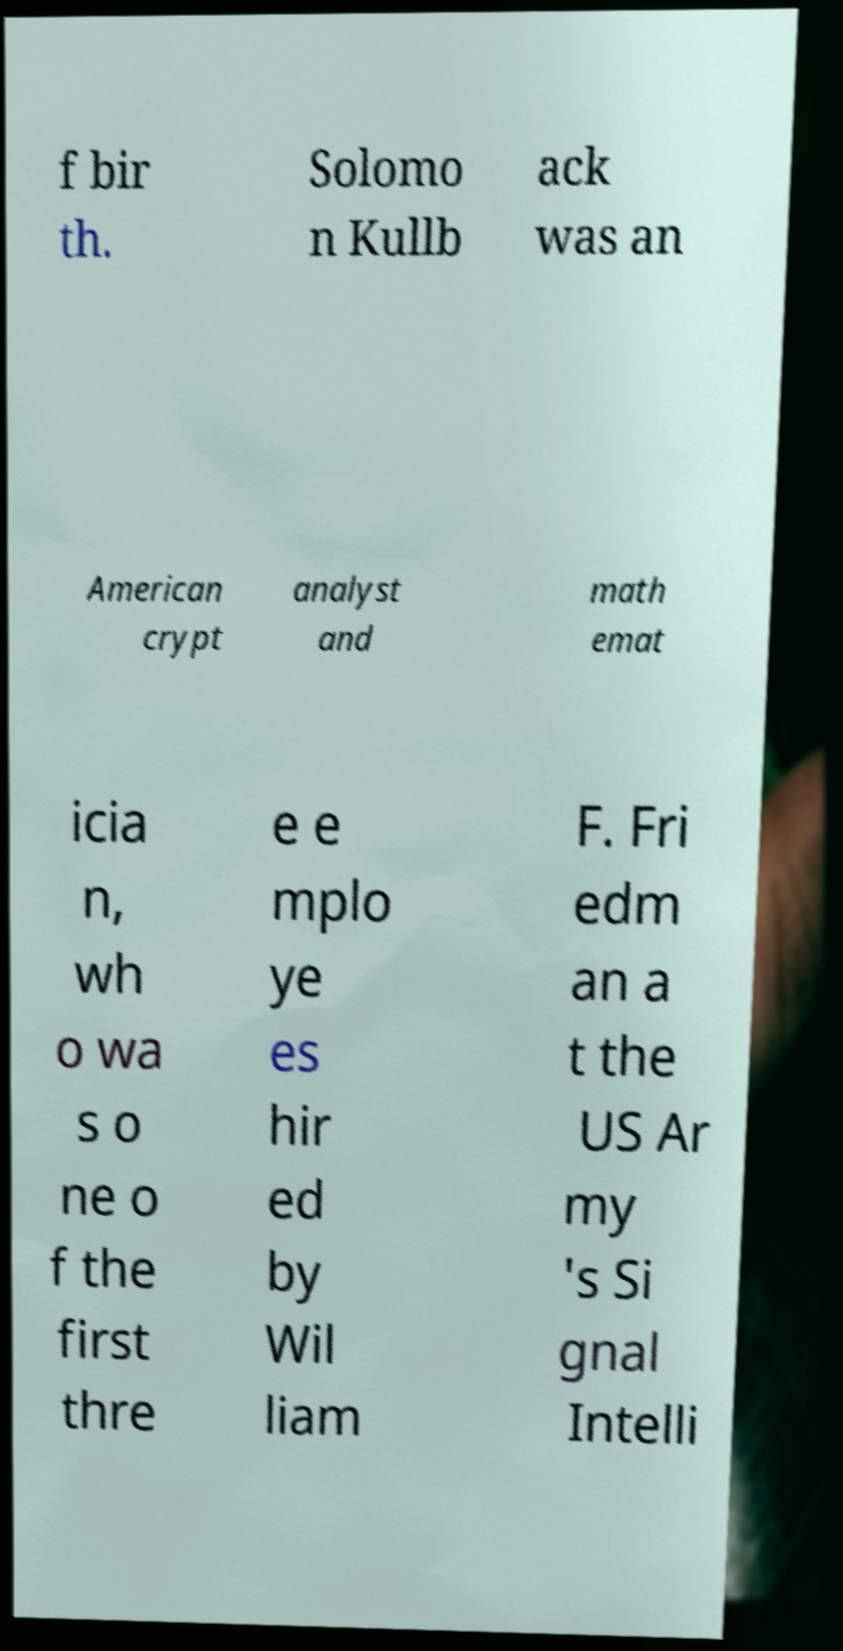For documentation purposes, I need the text within this image transcribed. Could you provide that? f bir th. Solomo n Kullb ack was an American crypt analyst and math emat icia n, wh o wa s o ne o f the first thre e e mplo ye es hir ed by Wil liam F. Fri edm an a t the US Ar my 's Si gnal Intelli 